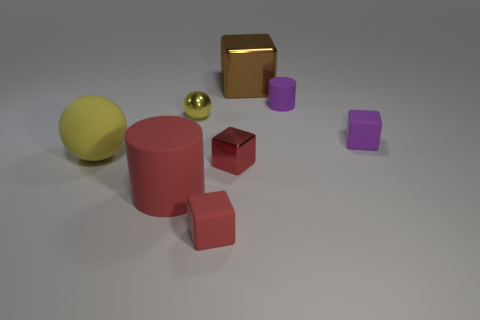How many other big blocks have the same material as the brown block?
Your answer should be very brief. 0. Are there any red metallic cubes that are to the right of the small block that is behind the metallic thing in front of the small yellow metallic sphere?
Your answer should be compact. No. There is a small yellow thing that is made of the same material as the big brown thing; what is its shape?
Offer a terse response. Sphere. Are there more small metal cubes than cyan balls?
Ensure brevity in your answer.  Yes. Do the yellow matte object and the matte thing that is in front of the large red cylinder have the same shape?
Your response must be concise. No. What material is the tiny purple cube?
Give a very brief answer. Rubber. There is a small matte thing that is behind the rubber block behind the tiny matte object to the left of the tiny matte cylinder; what is its color?
Offer a terse response. Purple. There is a tiny purple object that is the same shape as the big shiny object; what is its material?
Offer a very short reply. Rubber. What number of cylinders have the same size as the yellow rubber thing?
Your answer should be very brief. 1. What number of red things are there?
Your answer should be very brief. 3. 